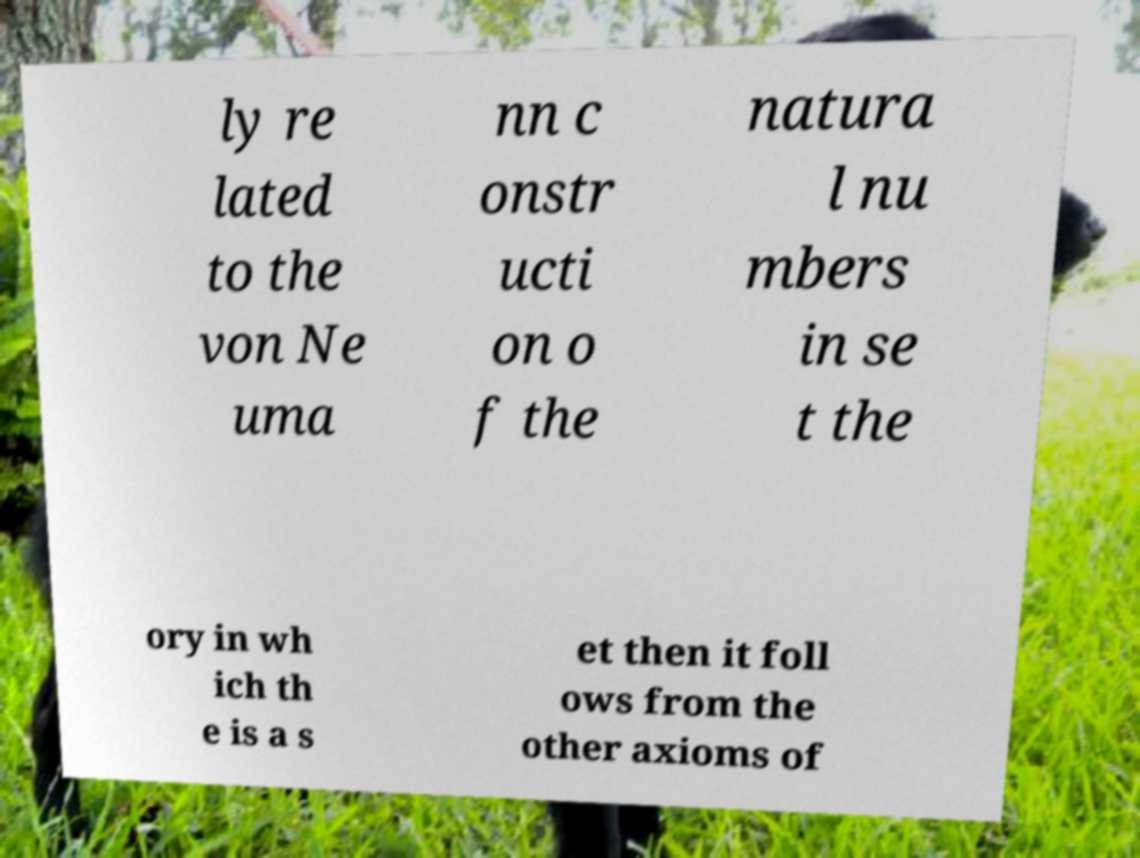Can you accurately transcribe the text from the provided image for me? ly re lated to the von Ne uma nn c onstr ucti on o f the natura l nu mbers in se t the ory in wh ich th e is a s et then it foll ows from the other axioms of 